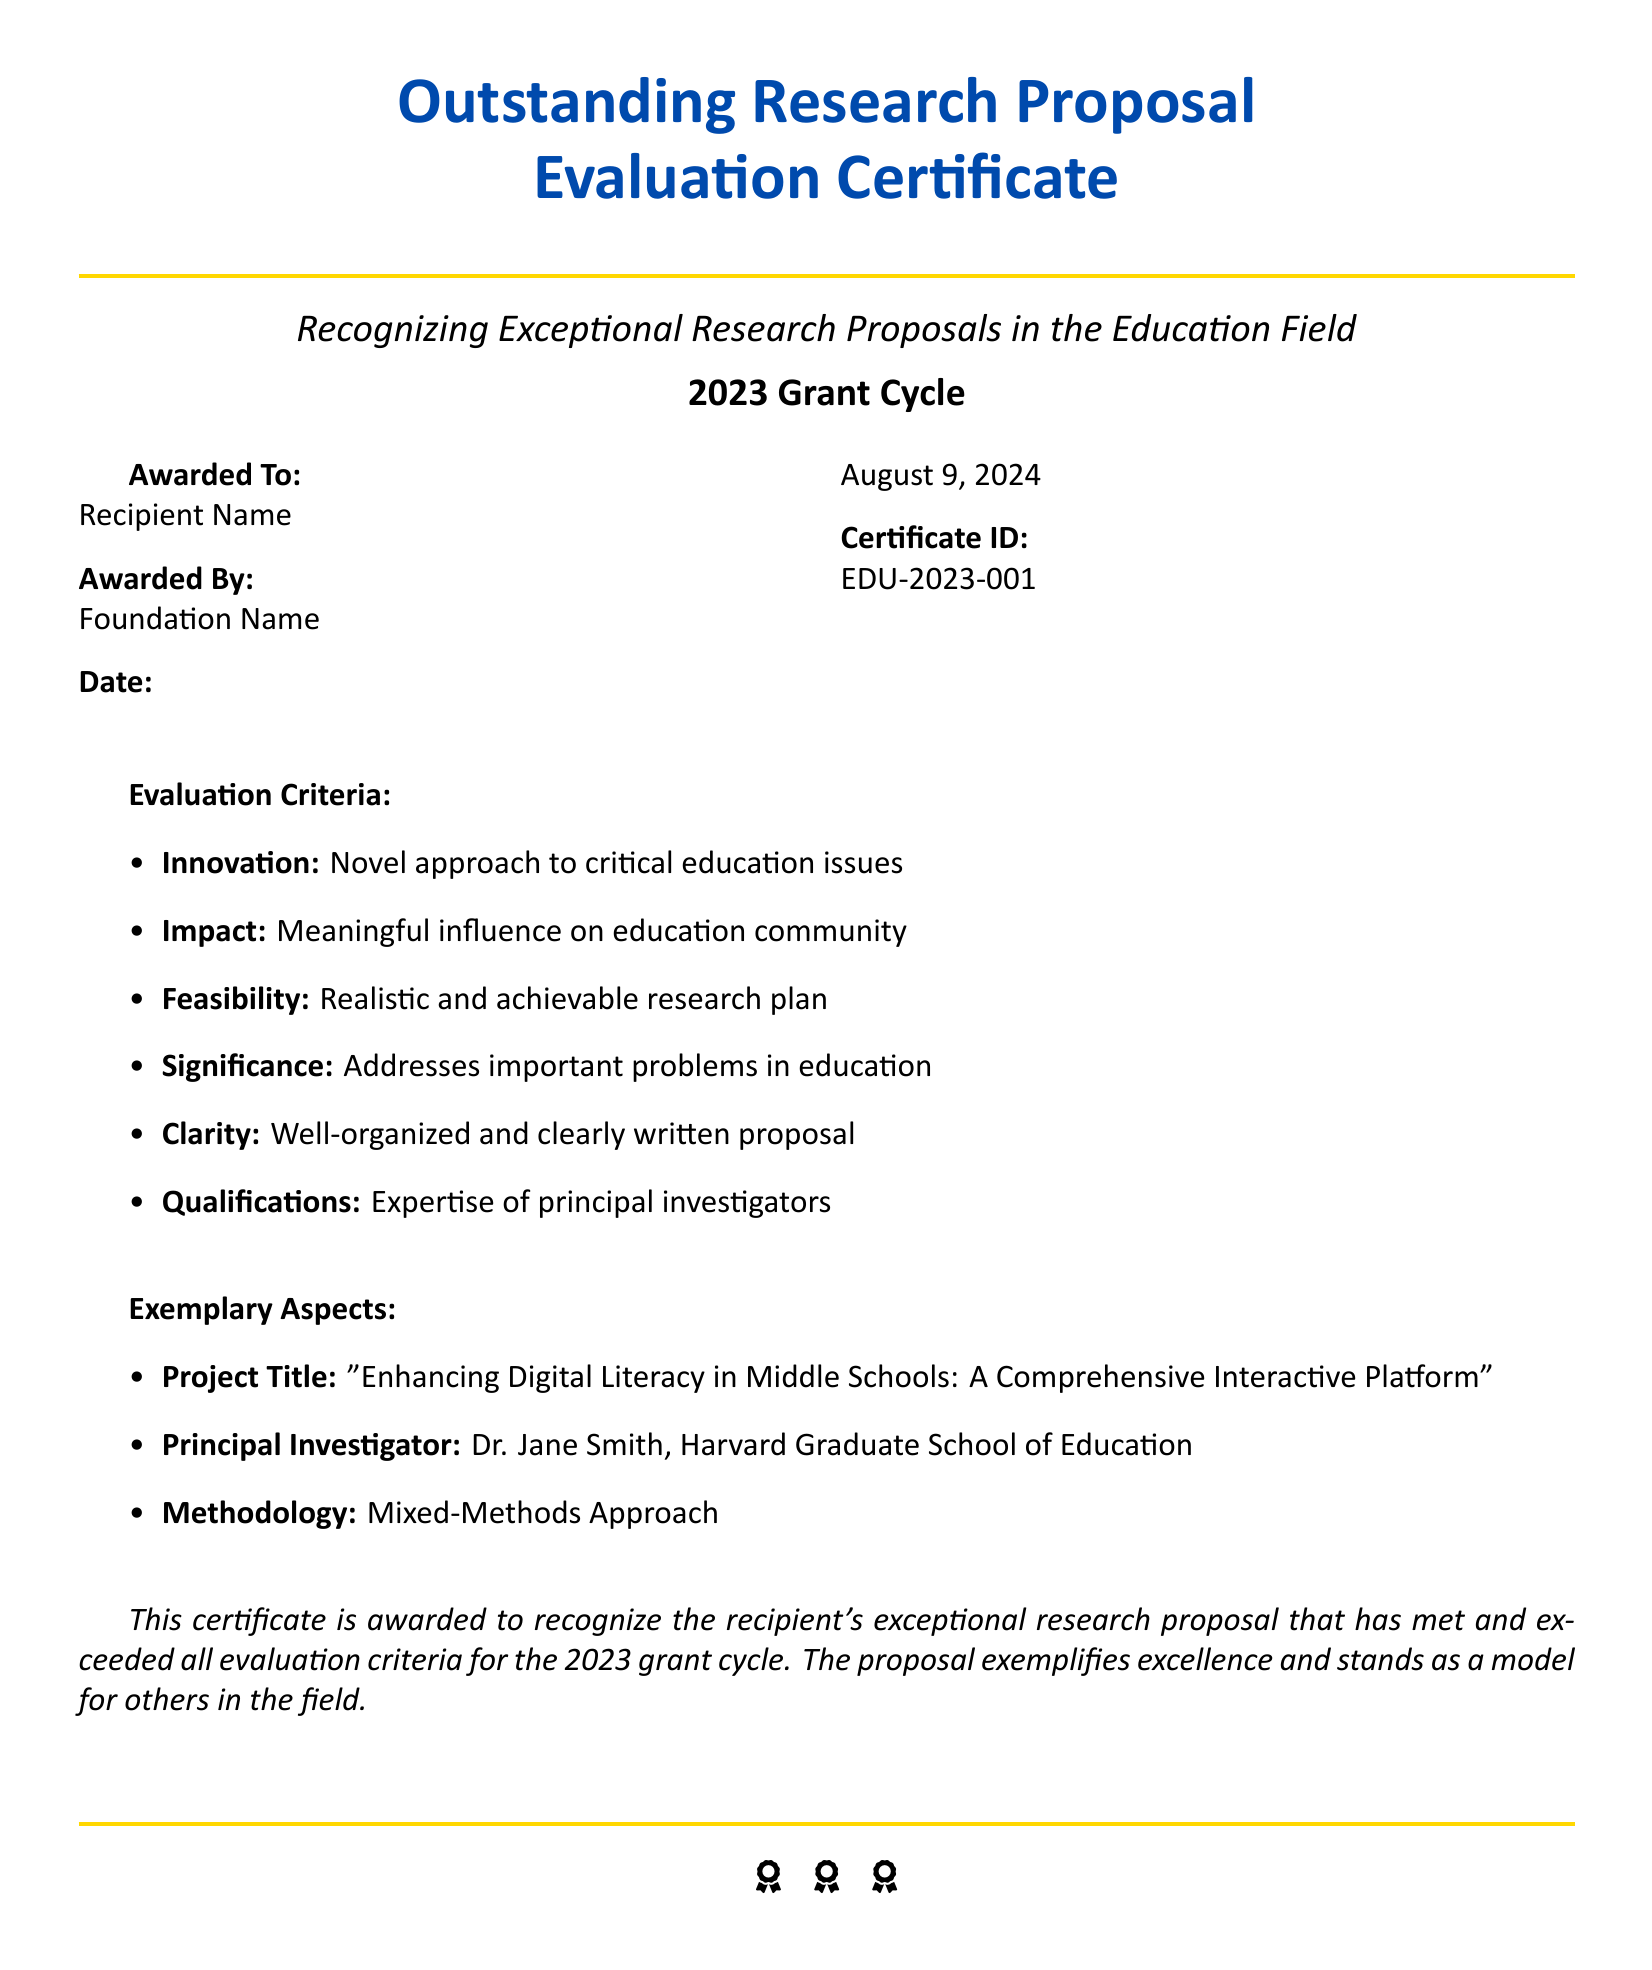What is the certificate ID? The certificate ID is specified in the document and is unique to this award.
Answer: EDU-2023-001 Who is the principal investigator? The document identifies the principal investigator of the exemplary proposal.
Answer: Dr. Jane Smith What is the awarded date? The document states that the certificate is awarded on the day it is printed.
Answer: Today's date What is the project title? The document clearly mentions the title of the exceptional research proposal.
Answer: Enhancing Digital Literacy in Middle Schools: A Comprehensive Interactive Platform Which foundation awarded the certificate? The awarding foundation's name is mentioned in the document.
Answer: Foundation Name How many exemplary aspects are listed? The document lists specific exemplary aspects of the awarded proposal.
Answer: Three What evaluation criteria is focused on realistic plans? This criterion evaluates the achievability of the research plan.
Answer: Feasibility What type of approach is used in the mentioned methodology? The document describes the approach taken in the research methodology.
Answer: Mixed-Methods Approach What is the main goal of the evaluation criteria? The purpose of these criteria is to assess research proposals effectively.
Answer: Recognizing exceptional research proposals 